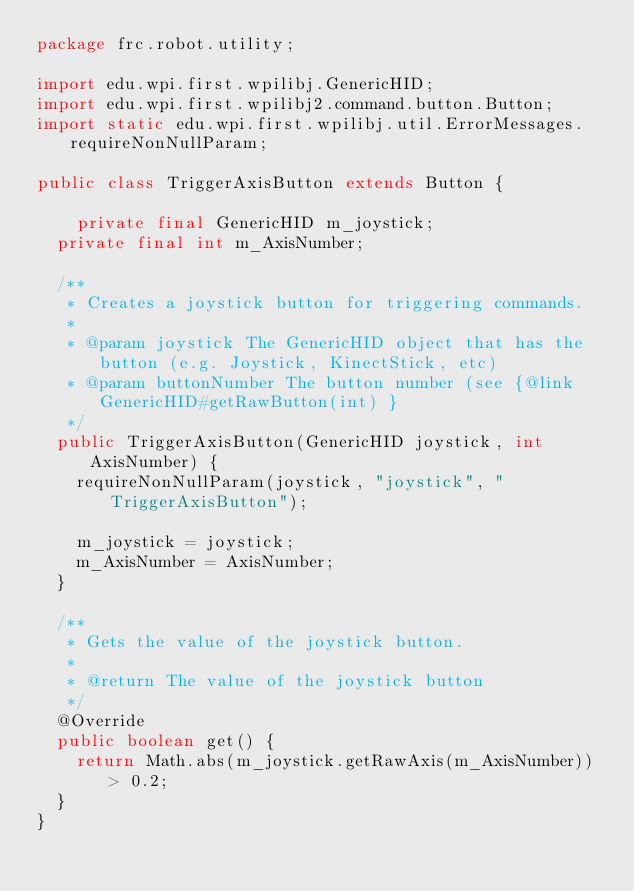Convert code to text. <code><loc_0><loc_0><loc_500><loc_500><_Java_>package frc.robot.utility;

import edu.wpi.first.wpilibj.GenericHID;
import edu.wpi.first.wpilibj2.command.button.Button;
import static edu.wpi.first.wpilibj.util.ErrorMessages.requireNonNullParam;

public class TriggerAxisButton extends Button {

    private final GenericHID m_joystick;
  private final int m_AxisNumber;

  /**
   * Creates a joystick button for triggering commands.
   *
   * @param joystick The GenericHID object that has the button (e.g. Joystick, KinectStick, etc)
   * @param buttonNumber The button number (see {@link GenericHID#getRawButton(int) }
   */
  public TriggerAxisButton(GenericHID joystick, int AxisNumber) {
    requireNonNullParam(joystick, "joystick", "TriggerAxisButton");

    m_joystick = joystick;
    m_AxisNumber = AxisNumber;
  }

  /**
   * Gets the value of the joystick button.
   *
   * @return The value of the joystick button
   */
  @Override
  public boolean get() {
    return Math.abs(m_joystick.getRawAxis(m_AxisNumber)) > 0.2;
  }
}</code> 